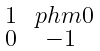<formula> <loc_0><loc_0><loc_500><loc_500>\begin{smallmatrix} 1 & \ p h m 0 \\ 0 & - 1 \end{smallmatrix}</formula> 